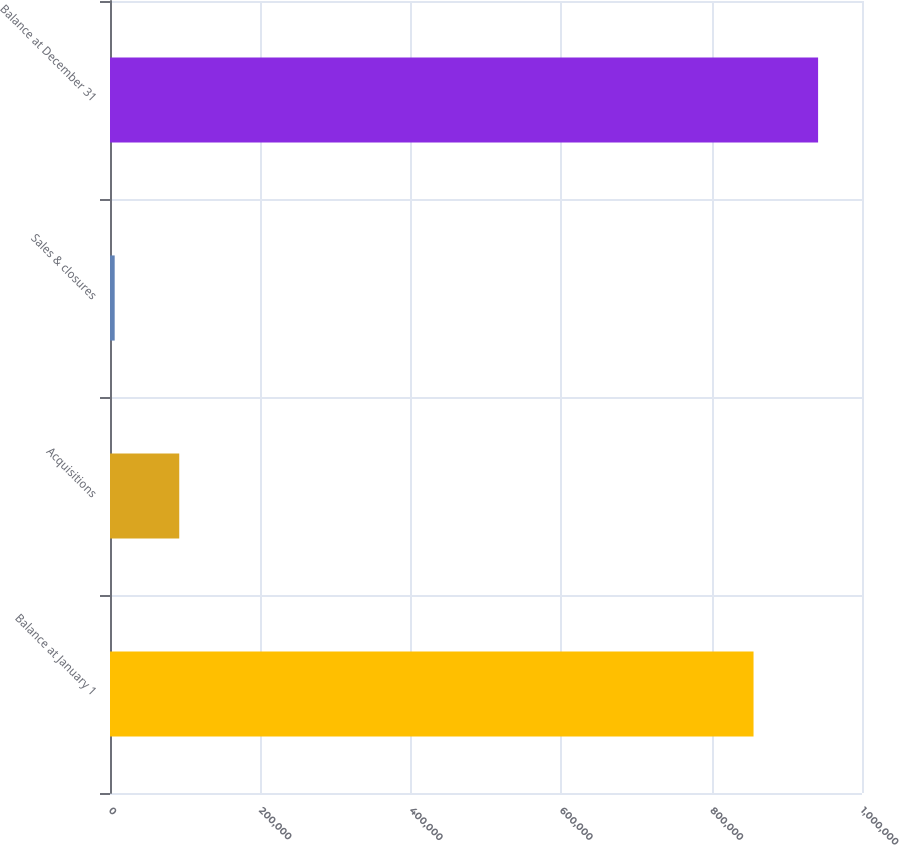Convert chart. <chart><loc_0><loc_0><loc_500><loc_500><bar_chart><fcel>Balance at January 1<fcel>Acquisitions<fcel>Sales & closures<fcel>Balance at December 31<nl><fcel>855760<fcel>92089.2<fcel>6234<fcel>941615<nl></chart> 